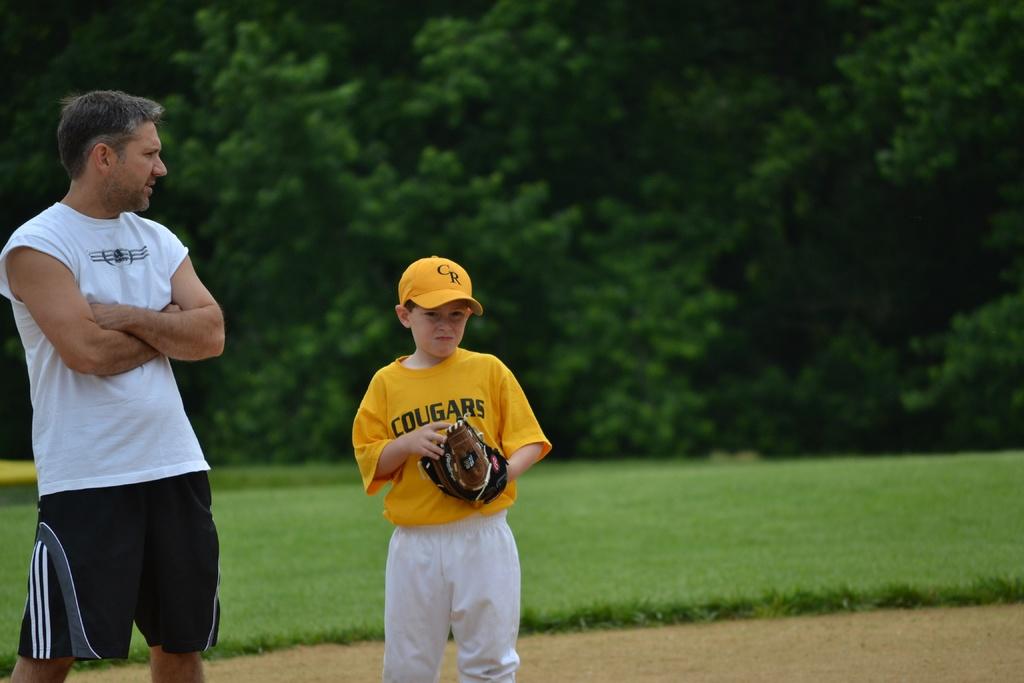What type of wild cat is mentioned on the boys jersey?
Ensure brevity in your answer.  Cougar. What letters are visible on the yellow hat?
Provide a succinct answer. Cr. 